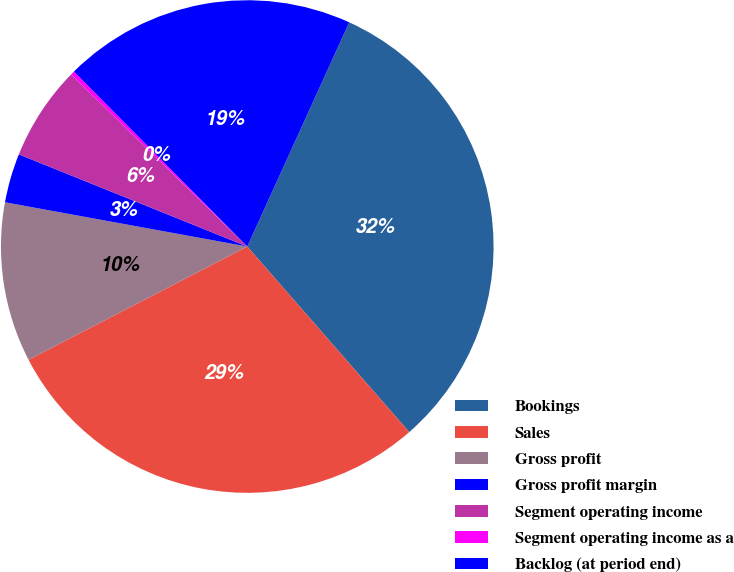<chart> <loc_0><loc_0><loc_500><loc_500><pie_chart><fcel>Bookings<fcel>Sales<fcel>Gross profit<fcel>Gross profit margin<fcel>Segment operating income<fcel>Segment operating income as a<fcel>Backlog (at period end)<nl><fcel>31.79%<fcel>28.82%<fcel>10.48%<fcel>3.23%<fcel>6.21%<fcel>0.26%<fcel>19.22%<nl></chart> 